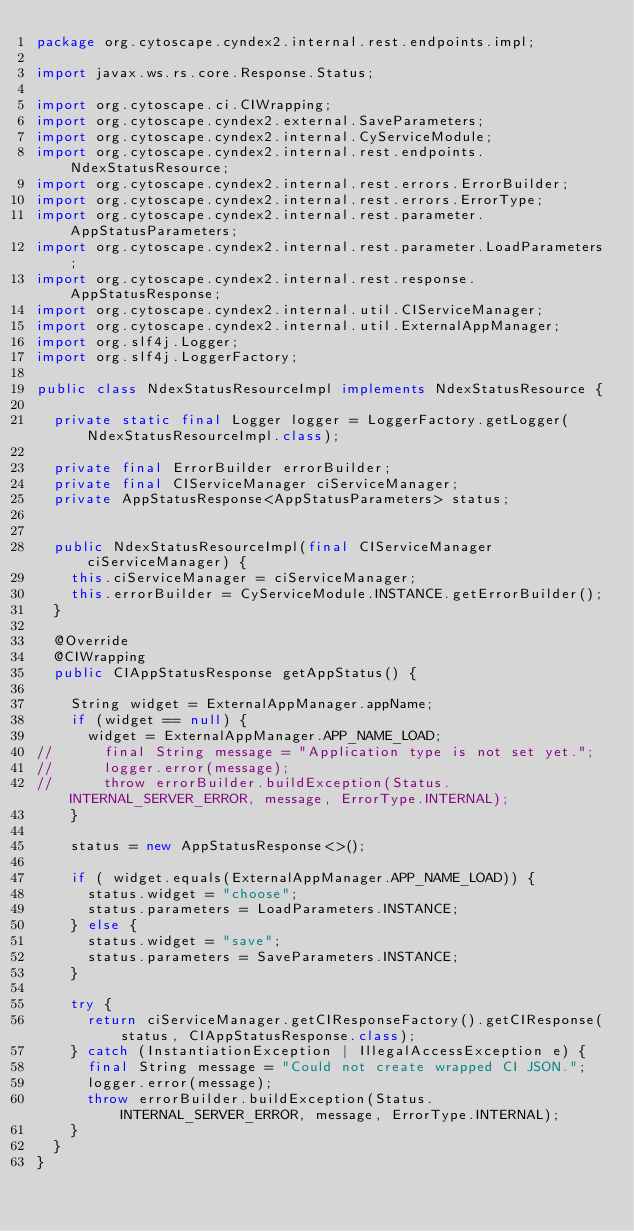<code> <loc_0><loc_0><loc_500><loc_500><_Java_>package org.cytoscape.cyndex2.internal.rest.endpoints.impl;

import javax.ws.rs.core.Response.Status;

import org.cytoscape.ci.CIWrapping;
import org.cytoscape.cyndex2.external.SaveParameters;
import org.cytoscape.cyndex2.internal.CyServiceModule;
import org.cytoscape.cyndex2.internal.rest.endpoints.NdexStatusResource;
import org.cytoscape.cyndex2.internal.rest.errors.ErrorBuilder;
import org.cytoscape.cyndex2.internal.rest.errors.ErrorType;
import org.cytoscape.cyndex2.internal.rest.parameter.AppStatusParameters;
import org.cytoscape.cyndex2.internal.rest.parameter.LoadParameters;
import org.cytoscape.cyndex2.internal.rest.response.AppStatusResponse;
import org.cytoscape.cyndex2.internal.util.CIServiceManager;
import org.cytoscape.cyndex2.internal.util.ExternalAppManager;
import org.slf4j.Logger;
import org.slf4j.LoggerFactory;

public class NdexStatusResourceImpl implements NdexStatusResource {

	private static final Logger logger = LoggerFactory.getLogger(NdexStatusResourceImpl.class);
	
	private final ErrorBuilder errorBuilder;
	private final CIServiceManager ciServiceManager;
	private AppStatusResponse<AppStatusParameters> status;


	public NdexStatusResourceImpl(final CIServiceManager ciServiceManager) {
		this.ciServiceManager = ciServiceManager;
		this.errorBuilder = CyServiceModule.INSTANCE.getErrorBuilder();
	}

	@Override
	@CIWrapping
	public CIAppStatusResponse getAppStatus() {

		String widget = ExternalAppManager.appName;
		if (widget == null) {
			widget = ExternalAppManager.APP_NAME_LOAD;
//			final String message = "Application type is not set yet.";
//			logger.error(message);
//			throw errorBuilder.buildException(Status.INTERNAL_SERVER_ERROR, message, ErrorType.INTERNAL);
		}

		status = new AppStatusResponse<>();

		if ( widget.equals(ExternalAppManager.APP_NAME_LOAD)) {
			status.widget = "choose";
			status.parameters = LoadParameters.INSTANCE;
		} else {
			status.widget = "save";
			status.parameters = SaveParameters.INSTANCE;
		}
		
		try {
			return ciServiceManager.getCIResponseFactory().getCIResponse(status, CIAppStatusResponse.class);
		} catch (InstantiationException | IllegalAccessException e) {
			final String message = "Could not create wrapped CI JSON.";
			logger.error(message);
			throw errorBuilder.buildException(Status.INTERNAL_SERVER_ERROR, message, ErrorType.INTERNAL);
		}
	}
}
</code> 